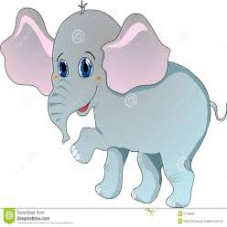You will be given an image of an elephant. The image could be of different categories like painting, cartoon, photograph, or sketch. Identify the image category. 
Options: (a) Cartoon (b) Photograph (c) Art painting (d) Sketch The depicted elephant falls under the category of a cartoon (a). This conclusion is supported by several distinguishing features of the image. It showcases exaggerated anatomical traits such as oversized ears and a simplified body outline, combined with vivid, whimsical colors that are not typically found in natural settings. Additionally, the elephant exhibits an emotional expression reflective of joyful characteristics often attributed to cartoon characters. The use of flat, uniform color fills and the absence of detailed textural elements further solidify its classification as a cartoon, rather than a photograph, a detailed art painting, or a sketch. 